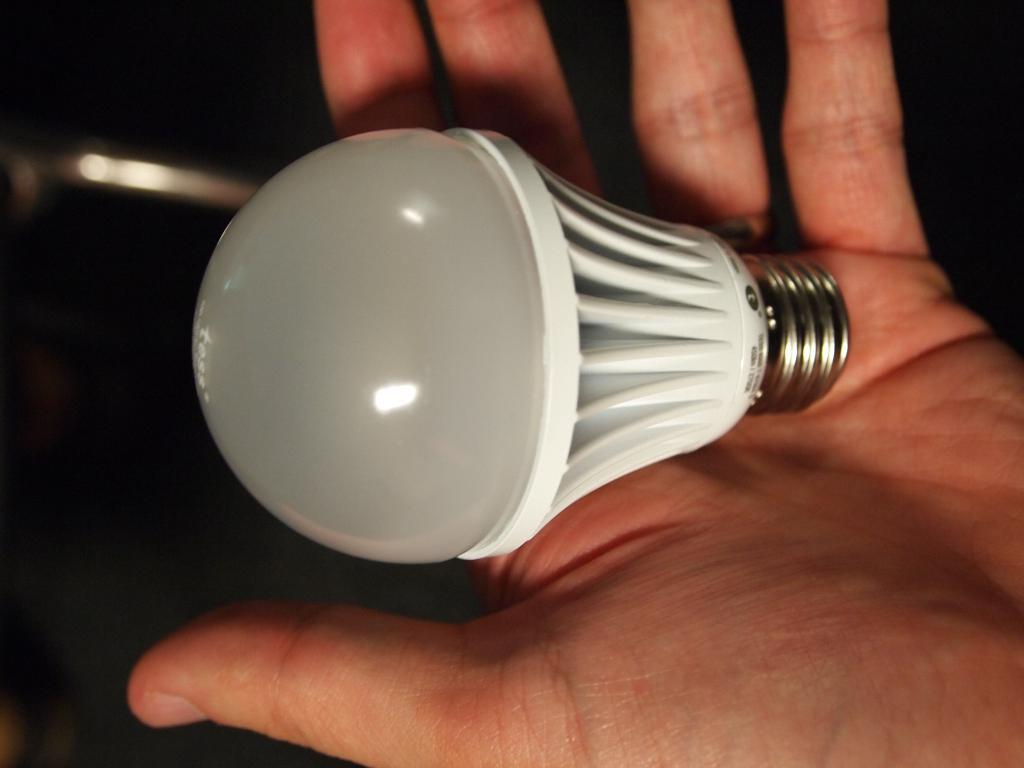What is the main subject of the image? There is a person in the image. What is the person holding in the image? The person is holding a bulb. Can you describe the background of the image? The backdrop of the image is dark. How many goldfish can be seen swimming in the image? There are no goldfish present in the image. What type of stick is the person using to hold the bulb in the image? The image does not show any sticks being used to hold the bulb. 